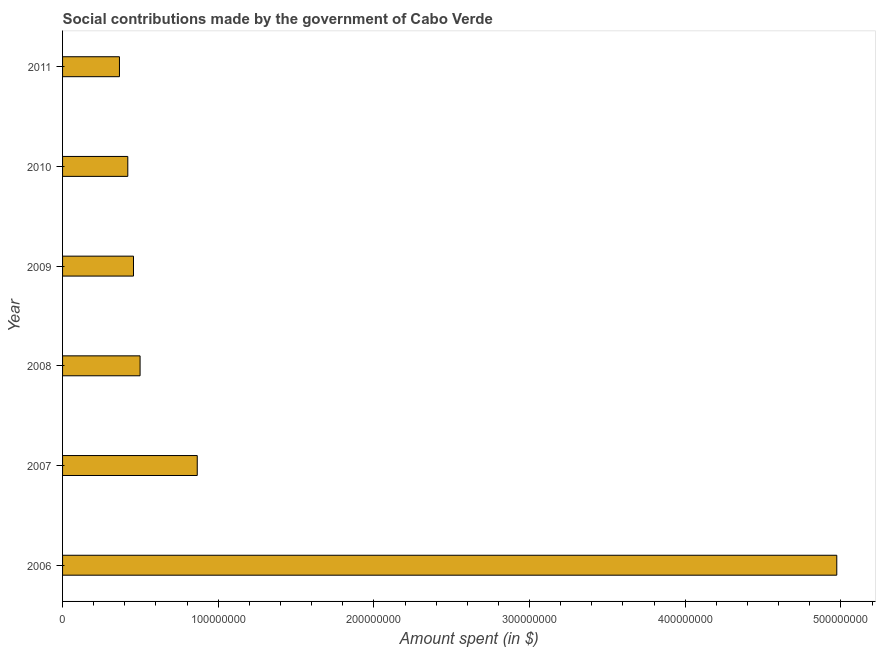Does the graph contain any zero values?
Your response must be concise. No. Does the graph contain grids?
Your answer should be compact. No. What is the title of the graph?
Your response must be concise. Social contributions made by the government of Cabo Verde. What is the label or title of the X-axis?
Offer a very short reply. Amount spent (in $). What is the label or title of the Y-axis?
Your response must be concise. Year. What is the amount spent in making social contributions in 2008?
Give a very brief answer. 4.98e+07. Across all years, what is the maximum amount spent in making social contributions?
Offer a very short reply. 4.97e+08. Across all years, what is the minimum amount spent in making social contributions?
Provide a short and direct response. 3.65e+07. In which year was the amount spent in making social contributions minimum?
Provide a short and direct response. 2011. What is the sum of the amount spent in making social contributions?
Give a very brief answer. 7.58e+08. What is the difference between the amount spent in making social contributions in 2007 and 2011?
Give a very brief answer. 5.00e+07. What is the average amount spent in making social contributions per year?
Your answer should be compact. 1.26e+08. What is the median amount spent in making social contributions?
Provide a short and direct response. 4.77e+07. What is the ratio of the amount spent in making social contributions in 2008 to that in 2010?
Make the answer very short. 1.19. Is the difference between the amount spent in making social contributions in 2009 and 2011 greater than the difference between any two years?
Provide a succinct answer. No. What is the difference between the highest and the second highest amount spent in making social contributions?
Your answer should be compact. 4.11e+08. Is the sum of the amount spent in making social contributions in 2007 and 2010 greater than the maximum amount spent in making social contributions across all years?
Provide a short and direct response. No. What is the difference between the highest and the lowest amount spent in making social contributions?
Make the answer very short. 4.61e+08. Are all the bars in the graph horizontal?
Ensure brevity in your answer.  Yes. How many years are there in the graph?
Your answer should be very brief. 6. What is the Amount spent (in $) of 2006?
Give a very brief answer. 4.97e+08. What is the Amount spent (in $) in 2007?
Your answer should be compact. 8.65e+07. What is the Amount spent (in $) of 2008?
Offer a terse response. 4.98e+07. What is the Amount spent (in $) in 2009?
Ensure brevity in your answer.  4.56e+07. What is the Amount spent (in $) of 2010?
Your answer should be compact. 4.19e+07. What is the Amount spent (in $) of 2011?
Your response must be concise. 3.65e+07. What is the difference between the Amount spent (in $) in 2006 and 2007?
Make the answer very short. 4.11e+08. What is the difference between the Amount spent (in $) in 2006 and 2008?
Your answer should be compact. 4.48e+08. What is the difference between the Amount spent (in $) in 2006 and 2009?
Your response must be concise. 4.52e+08. What is the difference between the Amount spent (in $) in 2006 and 2010?
Your response must be concise. 4.55e+08. What is the difference between the Amount spent (in $) in 2006 and 2011?
Your answer should be compact. 4.61e+08. What is the difference between the Amount spent (in $) in 2007 and 2008?
Provide a short and direct response. 3.67e+07. What is the difference between the Amount spent (in $) in 2007 and 2009?
Offer a terse response. 4.10e+07. What is the difference between the Amount spent (in $) in 2007 and 2010?
Ensure brevity in your answer.  4.46e+07. What is the difference between the Amount spent (in $) in 2007 and 2011?
Offer a terse response. 5.00e+07. What is the difference between the Amount spent (in $) in 2008 and 2009?
Give a very brief answer. 4.24e+06. What is the difference between the Amount spent (in $) in 2008 and 2010?
Your answer should be compact. 7.89e+06. What is the difference between the Amount spent (in $) in 2008 and 2011?
Offer a terse response. 1.33e+07. What is the difference between the Amount spent (in $) in 2009 and 2010?
Provide a short and direct response. 3.65e+06. What is the difference between the Amount spent (in $) in 2009 and 2011?
Make the answer very short. 9.01e+06. What is the difference between the Amount spent (in $) in 2010 and 2011?
Make the answer very short. 5.36e+06. What is the ratio of the Amount spent (in $) in 2006 to that in 2007?
Ensure brevity in your answer.  5.75. What is the ratio of the Amount spent (in $) in 2006 to that in 2008?
Your response must be concise. 9.99. What is the ratio of the Amount spent (in $) in 2006 to that in 2009?
Offer a terse response. 10.92. What is the ratio of the Amount spent (in $) in 2006 to that in 2010?
Offer a very short reply. 11.87. What is the ratio of the Amount spent (in $) in 2006 to that in 2011?
Your answer should be compact. 13.61. What is the ratio of the Amount spent (in $) in 2007 to that in 2008?
Your answer should be compact. 1.74. What is the ratio of the Amount spent (in $) in 2007 to that in 2009?
Provide a succinct answer. 1.9. What is the ratio of the Amount spent (in $) in 2007 to that in 2010?
Offer a terse response. 2.06. What is the ratio of the Amount spent (in $) in 2007 to that in 2011?
Offer a very short reply. 2.37. What is the ratio of the Amount spent (in $) in 2008 to that in 2009?
Offer a very short reply. 1.09. What is the ratio of the Amount spent (in $) in 2008 to that in 2010?
Offer a very short reply. 1.19. What is the ratio of the Amount spent (in $) in 2008 to that in 2011?
Make the answer very short. 1.36. What is the ratio of the Amount spent (in $) in 2009 to that in 2010?
Your answer should be very brief. 1.09. What is the ratio of the Amount spent (in $) in 2009 to that in 2011?
Your response must be concise. 1.25. What is the ratio of the Amount spent (in $) in 2010 to that in 2011?
Offer a terse response. 1.15. 